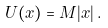<formula> <loc_0><loc_0><loc_500><loc_500>U ( x ) = M | x | \, .</formula> 